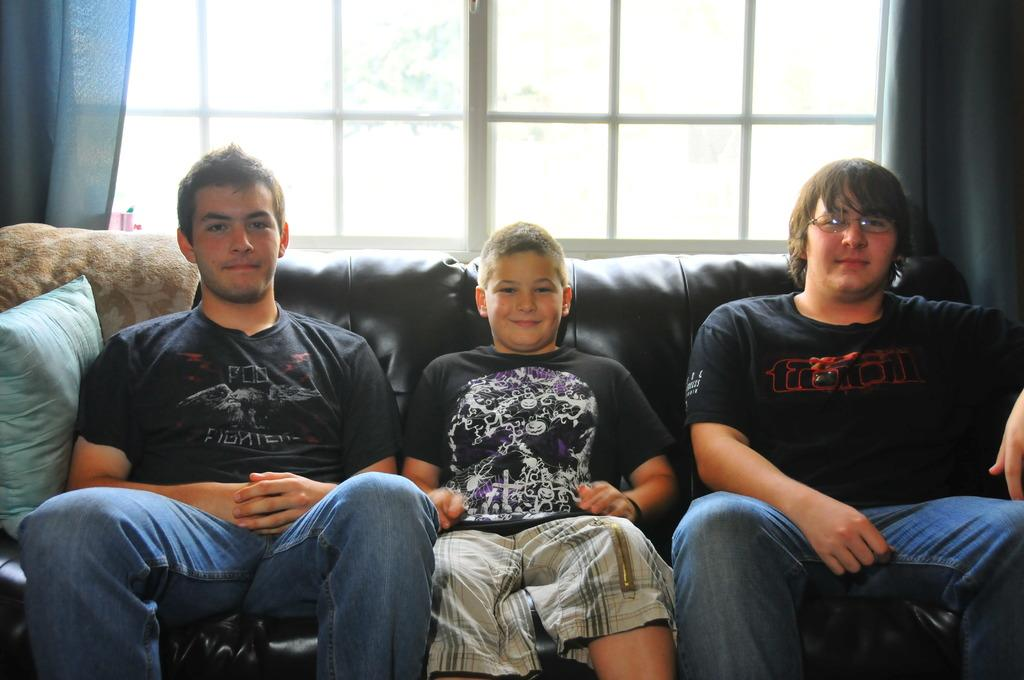How many boys are in the image? There are three boys in the image. What are the boys doing in the image? The boys are sitting on a sofa. What can be seen in the background of the image? There are windows with curtains in the background. Can you describe one of the boys in the image? One of the boys is wearing glasses (specs). What is the plot of the story unfolding in the image? There is no story or plot depicted in the image; it simply shows three boys sitting on a sofa. Can you tell me how much water is visible in the image? There is no water visible in the image. 